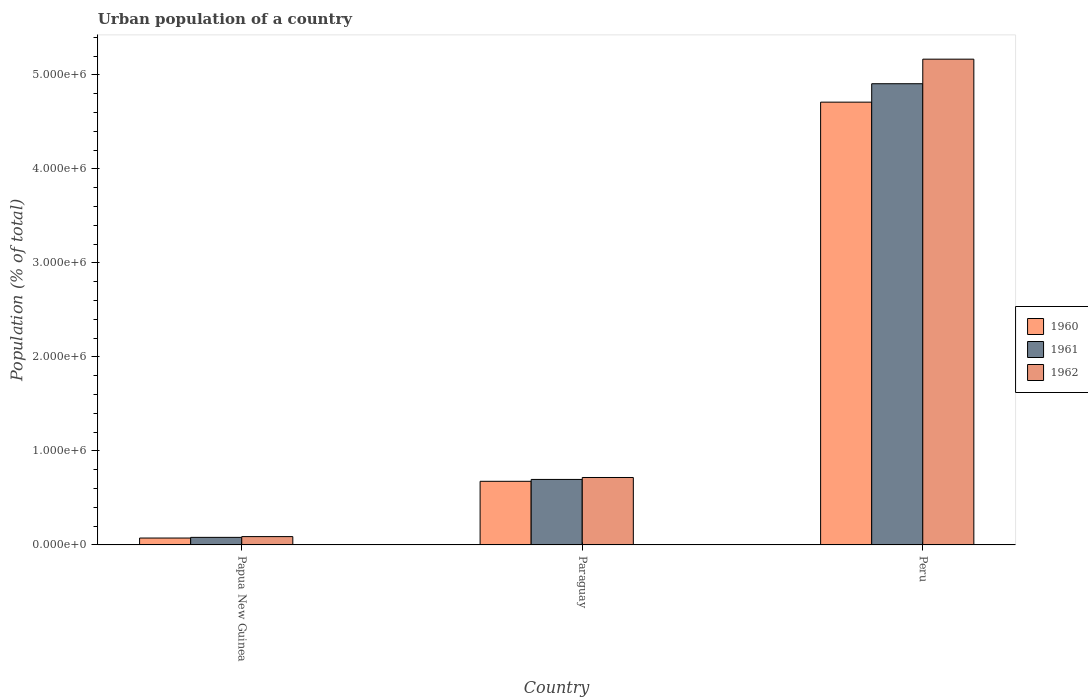How many different coloured bars are there?
Provide a short and direct response. 3. What is the label of the 1st group of bars from the left?
Your answer should be very brief. Papua New Guinea. What is the urban population in 1962 in Paraguay?
Provide a succinct answer. 7.17e+05. Across all countries, what is the maximum urban population in 1962?
Your response must be concise. 5.17e+06. Across all countries, what is the minimum urban population in 1962?
Give a very brief answer. 8.86e+04. In which country was the urban population in 1961 maximum?
Offer a very short reply. Peru. In which country was the urban population in 1962 minimum?
Your answer should be very brief. Papua New Guinea. What is the total urban population in 1962 in the graph?
Provide a short and direct response. 5.97e+06. What is the difference between the urban population in 1962 in Paraguay and that in Peru?
Provide a short and direct response. -4.45e+06. What is the difference between the urban population in 1962 in Papua New Guinea and the urban population in 1961 in Paraguay?
Your response must be concise. -6.08e+05. What is the average urban population in 1962 per country?
Make the answer very short. 1.99e+06. What is the difference between the urban population of/in 1961 and urban population of/in 1962 in Papua New Guinea?
Offer a very short reply. -8034. In how many countries, is the urban population in 1960 greater than 3800000 %?
Ensure brevity in your answer.  1. What is the ratio of the urban population in 1960 in Papua New Guinea to that in Paraguay?
Offer a very short reply. 0.11. Is the urban population in 1961 in Paraguay less than that in Peru?
Offer a terse response. Yes. What is the difference between the highest and the second highest urban population in 1961?
Keep it short and to the point. 6.16e+05. What is the difference between the highest and the lowest urban population in 1960?
Offer a terse response. 4.64e+06. Is the sum of the urban population in 1960 in Paraguay and Peru greater than the maximum urban population in 1962 across all countries?
Make the answer very short. Yes. Is it the case that in every country, the sum of the urban population in 1960 and urban population in 1962 is greater than the urban population in 1961?
Ensure brevity in your answer.  Yes. How many bars are there?
Your response must be concise. 9. Are all the bars in the graph horizontal?
Your response must be concise. No. How many countries are there in the graph?
Provide a succinct answer. 3. What is the difference between two consecutive major ticks on the Y-axis?
Give a very brief answer. 1.00e+06. Does the graph contain grids?
Provide a short and direct response. No. How many legend labels are there?
Make the answer very short. 3. What is the title of the graph?
Provide a short and direct response. Urban population of a country. What is the label or title of the Y-axis?
Make the answer very short. Population (% of total). What is the Population (% of total) of 1960 in Papua New Guinea?
Offer a terse response. 7.33e+04. What is the Population (% of total) of 1961 in Papua New Guinea?
Make the answer very short. 8.05e+04. What is the Population (% of total) of 1962 in Papua New Guinea?
Ensure brevity in your answer.  8.86e+04. What is the Population (% of total) in 1960 in Paraguay?
Make the answer very short. 6.77e+05. What is the Population (% of total) in 1961 in Paraguay?
Your answer should be compact. 6.97e+05. What is the Population (% of total) of 1962 in Paraguay?
Provide a succinct answer. 7.17e+05. What is the Population (% of total) in 1960 in Peru?
Offer a terse response. 4.71e+06. What is the Population (% of total) of 1961 in Peru?
Provide a succinct answer. 4.91e+06. What is the Population (% of total) of 1962 in Peru?
Offer a very short reply. 5.17e+06. Across all countries, what is the maximum Population (% of total) of 1960?
Give a very brief answer. 4.71e+06. Across all countries, what is the maximum Population (% of total) of 1961?
Your response must be concise. 4.91e+06. Across all countries, what is the maximum Population (% of total) in 1962?
Give a very brief answer. 5.17e+06. Across all countries, what is the minimum Population (% of total) of 1960?
Keep it short and to the point. 7.33e+04. Across all countries, what is the minimum Population (% of total) in 1961?
Provide a short and direct response. 8.05e+04. Across all countries, what is the minimum Population (% of total) of 1962?
Your answer should be very brief. 8.86e+04. What is the total Population (% of total) in 1960 in the graph?
Ensure brevity in your answer.  5.46e+06. What is the total Population (% of total) in 1961 in the graph?
Provide a succinct answer. 5.68e+06. What is the total Population (% of total) in 1962 in the graph?
Your answer should be compact. 5.97e+06. What is the difference between the Population (% of total) in 1960 in Papua New Guinea and that in Paraguay?
Your answer should be compact. -6.04e+05. What is the difference between the Population (% of total) in 1961 in Papua New Guinea and that in Paraguay?
Make the answer very short. -6.16e+05. What is the difference between the Population (% of total) of 1962 in Papua New Guinea and that in Paraguay?
Provide a short and direct response. -6.29e+05. What is the difference between the Population (% of total) of 1960 in Papua New Guinea and that in Peru?
Your answer should be very brief. -4.64e+06. What is the difference between the Population (% of total) in 1961 in Papua New Guinea and that in Peru?
Offer a terse response. -4.83e+06. What is the difference between the Population (% of total) in 1962 in Papua New Guinea and that in Peru?
Give a very brief answer. -5.08e+06. What is the difference between the Population (% of total) of 1960 in Paraguay and that in Peru?
Provide a short and direct response. -4.03e+06. What is the difference between the Population (% of total) in 1961 in Paraguay and that in Peru?
Provide a succinct answer. -4.21e+06. What is the difference between the Population (% of total) in 1962 in Paraguay and that in Peru?
Provide a short and direct response. -4.45e+06. What is the difference between the Population (% of total) of 1960 in Papua New Guinea and the Population (% of total) of 1961 in Paraguay?
Provide a succinct answer. -6.23e+05. What is the difference between the Population (% of total) in 1960 in Papua New Guinea and the Population (% of total) in 1962 in Paraguay?
Make the answer very short. -6.44e+05. What is the difference between the Population (% of total) in 1961 in Papua New Guinea and the Population (% of total) in 1962 in Paraguay?
Your answer should be compact. -6.37e+05. What is the difference between the Population (% of total) in 1960 in Papua New Guinea and the Population (% of total) in 1961 in Peru?
Ensure brevity in your answer.  -4.83e+06. What is the difference between the Population (% of total) of 1960 in Papua New Guinea and the Population (% of total) of 1962 in Peru?
Offer a terse response. -5.09e+06. What is the difference between the Population (% of total) in 1961 in Papua New Guinea and the Population (% of total) in 1962 in Peru?
Make the answer very short. -5.09e+06. What is the difference between the Population (% of total) in 1960 in Paraguay and the Population (% of total) in 1961 in Peru?
Give a very brief answer. -4.23e+06. What is the difference between the Population (% of total) of 1960 in Paraguay and the Population (% of total) of 1962 in Peru?
Offer a very short reply. -4.49e+06. What is the difference between the Population (% of total) of 1961 in Paraguay and the Population (% of total) of 1962 in Peru?
Your answer should be compact. -4.47e+06. What is the average Population (% of total) in 1960 per country?
Ensure brevity in your answer.  1.82e+06. What is the average Population (% of total) in 1961 per country?
Ensure brevity in your answer.  1.89e+06. What is the average Population (% of total) of 1962 per country?
Make the answer very short. 1.99e+06. What is the difference between the Population (% of total) of 1960 and Population (% of total) of 1961 in Papua New Guinea?
Offer a terse response. -7253. What is the difference between the Population (% of total) of 1960 and Population (% of total) of 1962 in Papua New Guinea?
Make the answer very short. -1.53e+04. What is the difference between the Population (% of total) in 1961 and Population (% of total) in 1962 in Papua New Guinea?
Provide a short and direct response. -8034. What is the difference between the Population (% of total) in 1960 and Population (% of total) in 1961 in Paraguay?
Your answer should be compact. -1.99e+04. What is the difference between the Population (% of total) of 1960 and Population (% of total) of 1962 in Paraguay?
Make the answer very short. -4.05e+04. What is the difference between the Population (% of total) of 1961 and Population (% of total) of 1962 in Paraguay?
Your answer should be compact. -2.06e+04. What is the difference between the Population (% of total) in 1960 and Population (% of total) in 1961 in Peru?
Give a very brief answer. -1.96e+05. What is the difference between the Population (% of total) in 1960 and Population (% of total) in 1962 in Peru?
Give a very brief answer. -4.57e+05. What is the difference between the Population (% of total) of 1961 and Population (% of total) of 1962 in Peru?
Keep it short and to the point. -2.61e+05. What is the ratio of the Population (% of total) of 1960 in Papua New Guinea to that in Paraguay?
Make the answer very short. 0.11. What is the ratio of the Population (% of total) of 1961 in Papua New Guinea to that in Paraguay?
Keep it short and to the point. 0.12. What is the ratio of the Population (% of total) of 1962 in Papua New Guinea to that in Paraguay?
Your answer should be very brief. 0.12. What is the ratio of the Population (% of total) of 1960 in Papua New Guinea to that in Peru?
Make the answer very short. 0.02. What is the ratio of the Population (% of total) of 1961 in Papua New Guinea to that in Peru?
Make the answer very short. 0.02. What is the ratio of the Population (% of total) in 1962 in Papua New Guinea to that in Peru?
Give a very brief answer. 0.02. What is the ratio of the Population (% of total) in 1960 in Paraguay to that in Peru?
Ensure brevity in your answer.  0.14. What is the ratio of the Population (% of total) in 1961 in Paraguay to that in Peru?
Give a very brief answer. 0.14. What is the ratio of the Population (% of total) of 1962 in Paraguay to that in Peru?
Provide a succinct answer. 0.14. What is the difference between the highest and the second highest Population (% of total) in 1960?
Offer a very short reply. 4.03e+06. What is the difference between the highest and the second highest Population (% of total) in 1961?
Your answer should be compact. 4.21e+06. What is the difference between the highest and the second highest Population (% of total) of 1962?
Offer a terse response. 4.45e+06. What is the difference between the highest and the lowest Population (% of total) in 1960?
Your answer should be very brief. 4.64e+06. What is the difference between the highest and the lowest Population (% of total) of 1961?
Offer a very short reply. 4.83e+06. What is the difference between the highest and the lowest Population (% of total) of 1962?
Your answer should be compact. 5.08e+06. 